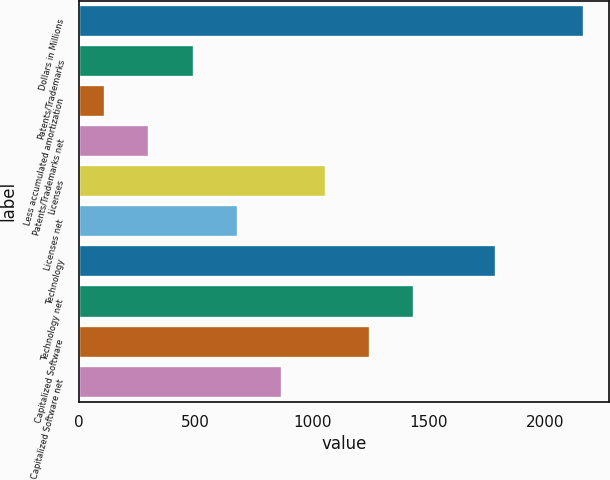<chart> <loc_0><loc_0><loc_500><loc_500><bar_chart><fcel>Dollars in Millions<fcel>Patents/Trademarks<fcel>Less accumulated amortization<fcel>Patents/Trademarks net<fcel>Licenses<fcel>Licenses net<fcel>Technology<fcel>Technology net<fcel>Capitalized Software<fcel>Capitalized Software net<nl><fcel>2165.4<fcel>491.4<fcel>113<fcel>302.2<fcel>1059<fcel>680.6<fcel>1787<fcel>1437.4<fcel>1248.2<fcel>869.8<nl></chart> 